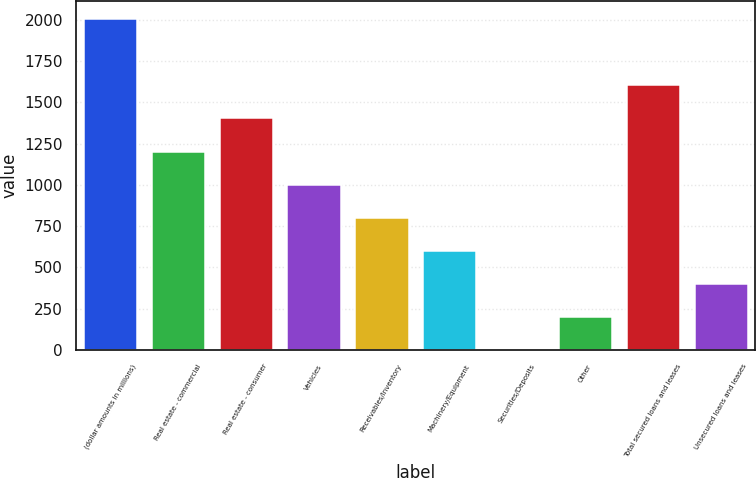Convert chart to OTSL. <chart><loc_0><loc_0><loc_500><loc_500><bar_chart><fcel>(dollar amounts in millions)<fcel>Real estate - commercial<fcel>Real estate - consumer<fcel>Vehicles<fcel>Receivables/Inventory<fcel>Machinery/Equipment<fcel>Securities/Deposits<fcel>Other<fcel>Total secured loans and leases<fcel>Unsecured loans and leases<nl><fcel>2011<fcel>1207.4<fcel>1408.3<fcel>1006.5<fcel>805.6<fcel>604.7<fcel>2<fcel>202.9<fcel>1609.2<fcel>403.8<nl></chart> 